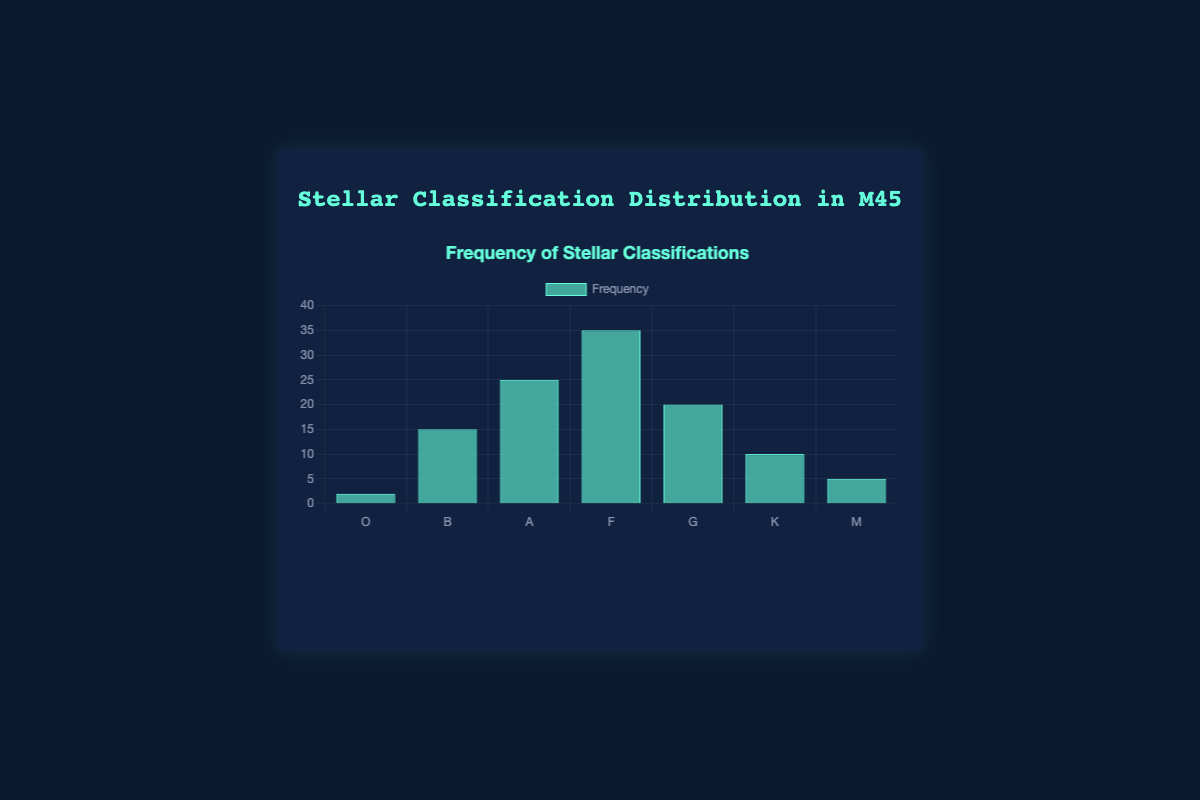Which stellar classification has the highest frequency in the star cluster M45? By looking at the heights of the bars, the bar for classification F is the tallest, indicating the highest frequency.
Answer: F Which stellar classification has the lowest frequency in the star cluster M45? By observing the bar heights, the bar for classification O is the shortest, indicating the lowest frequency.
Answer: O What is the difference in frequency between the most common and the least common stellar classifications? The most common classification is F with a frequency of 35, and the least common is O with a frequency of 2. The difference is 35 - 2.
Answer: 33 What is the combined frequency of classifications G and A? The frequency for G is 20 and for A is 25. Summing them up, 20 + 25 = 45.
Answer: 45 How does the frequency of classification B compare to classification K? The frequency for B is 15 and for K is 10. B has a higher frequency compared to K.
Answer: B has a higher frequency Which stellar classifications have frequencies greater than 20? The bars for classifications A (25), F (35), and G (20) are taller than the bar at the 20 mark.
Answer: A, F, G What is the average frequency of classifications B, A, and K? The frequencies for B, A, and K are 15, 25, and 10 respectively. Summing these gives 15 + 25 + 10 = 50. The average is 50 / 3 = 16.67.
Answer: 16.67 Is the frequency of M greater than or less than the frequency of G? The frequency of M is 5 and the frequency of G is 20. M is less than G.
Answer: Less What is the visual color of the bars representing stellar classification frequencies? The bars in the chart are colored blue, specifically shown as light blue.
Answer: Blue If you add the frequencies of classifications O and B, what is the result? The frequency for O is 2 and for B is 15. Adding these together, 2 + 15 = 17.
Answer: 17 